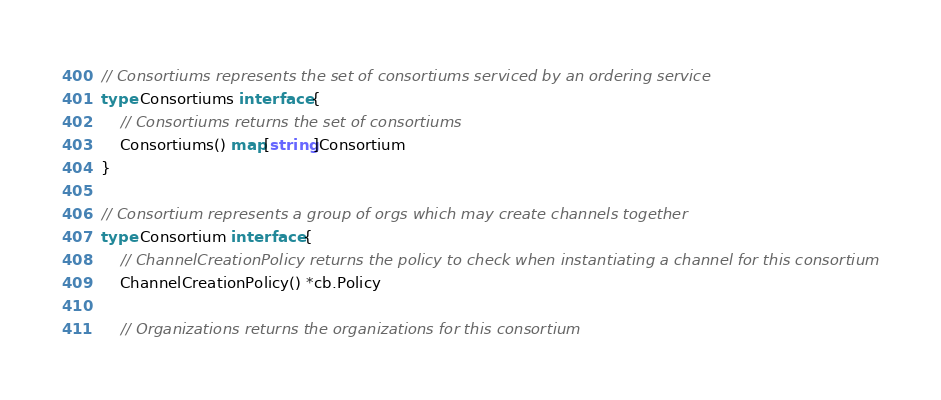<code> <loc_0><loc_0><loc_500><loc_500><_Go_>// Consortiums represents the set of consortiums serviced by an ordering service
type Consortiums interface {
	// Consortiums returns the set of consortiums
	Consortiums() map[string]Consortium
}

// Consortium represents a group of orgs which may create channels together
type Consortium interface {
	// ChannelCreationPolicy returns the policy to check when instantiating a channel for this consortium
	ChannelCreationPolicy() *cb.Policy

	// Organizations returns the organizations for this consortium</code> 